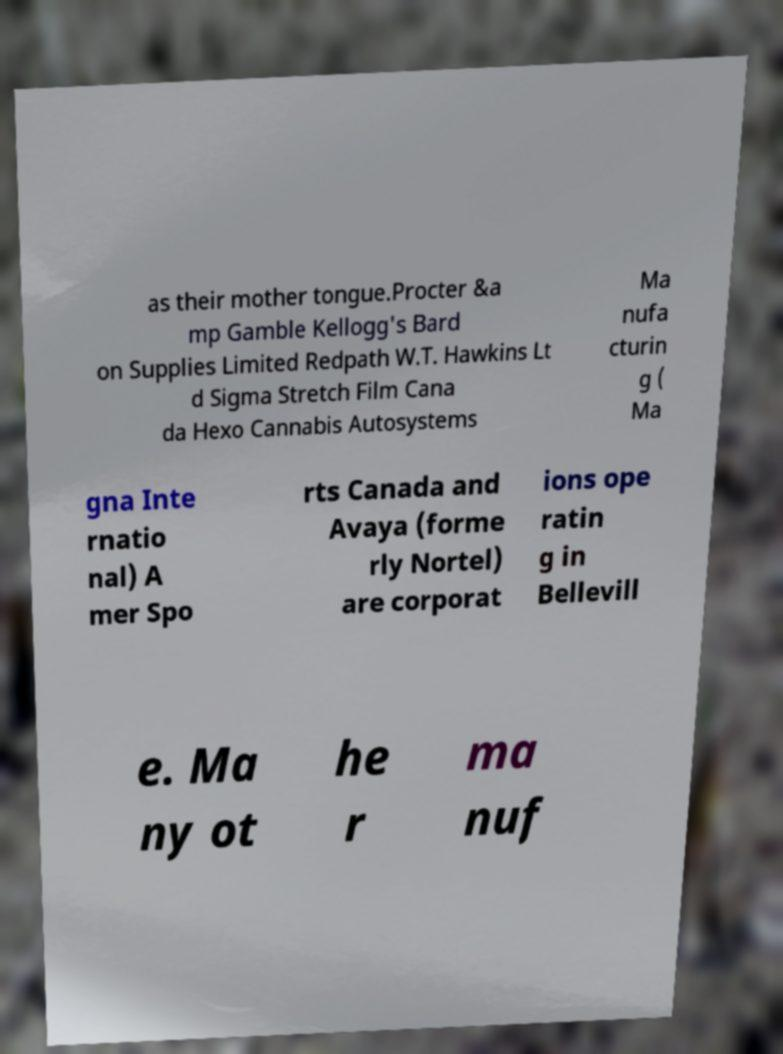What messages or text are displayed in this image? I need them in a readable, typed format. as their mother tongue.Procter &a mp Gamble Kellogg's Bard on Supplies Limited Redpath W.T. Hawkins Lt d Sigma Stretch Film Cana da Hexo Cannabis Autosystems Ma nufa cturin g ( Ma gna Inte rnatio nal) A mer Spo rts Canada and Avaya (forme rly Nortel) are corporat ions ope ratin g in Bellevill e. Ma ny ot he r ma nuf 